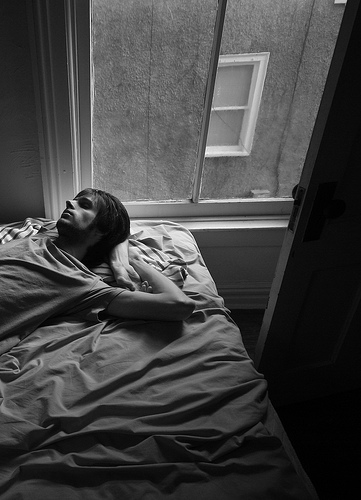Are there windows that are not black? Yes, there are windows that are not black. 